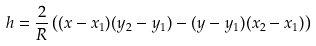Convert formula to latex. <formula><loc_0><loc_0><loc_500><loc_500>h = \frac { 2 } { R } \left ( ( x - x _ { 1 } ) ( y _ { 2 } - y _ { 1 } ) - ( y - y _ { 1 } ) ( x _ { 2 } - x _ { 1 } ) \right )</formula> 